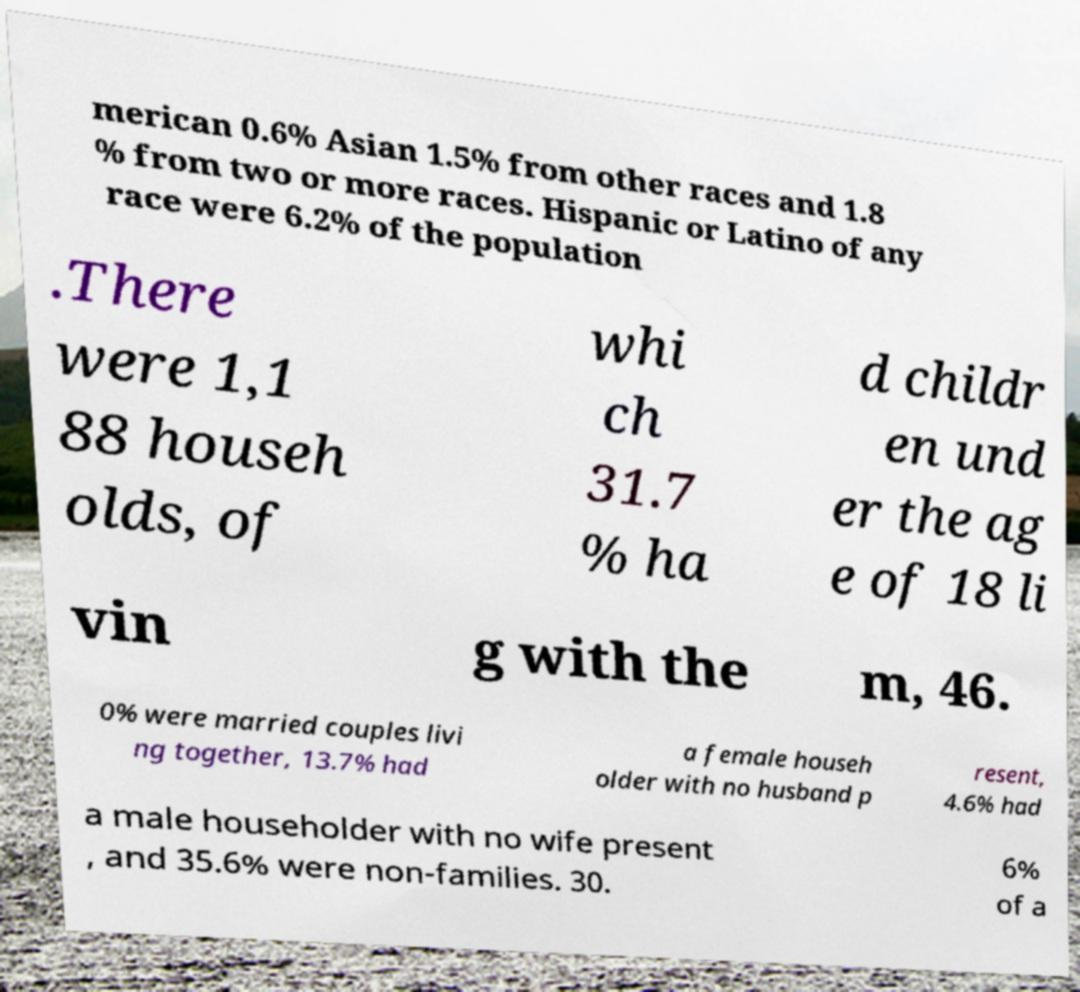Could you extract and type out the text from this image? merican 0.6% Asian 1.5% from other races and 1.8 % from two or more races. Hispanic or Latino of any race were 6.2% of the population .There were 1,1 88 househ olds, of whi ch 31.7 % ha d childr en und er the ag e of 18 li vin g with the m, 46. 0% were married couples livi ng together, 13.7% had a female househ older with no husband p resent, 4.6% had a male householder with no wife present , and 35.6% were non-families. 30. 6% of a 